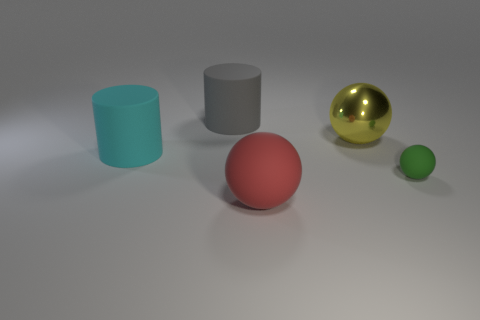Subtract all big metallic balls. How many balls are left? 2 Add 1 cyan things. How many objects exist? 6 Subtract 1 cylinders. How many cylinders are left? 1 Subtract all yellow spheres. How many spheres are left? 2 Subtract 0 cyan spheres. How many objects are left? 5 Subtract all balls. How many objects are left? 2 Subtract all green spheres. Subtract all brown cylinders. How many spheres are left? 2 Subtract all large green blocks. Subtract all large red spheres. How many objects are left? 4 Add 4 green rubber spheres. How many green rubber spheres are left? 5 Add 3 gray shiny cubes. How many gray shiny cubes exist? 3 